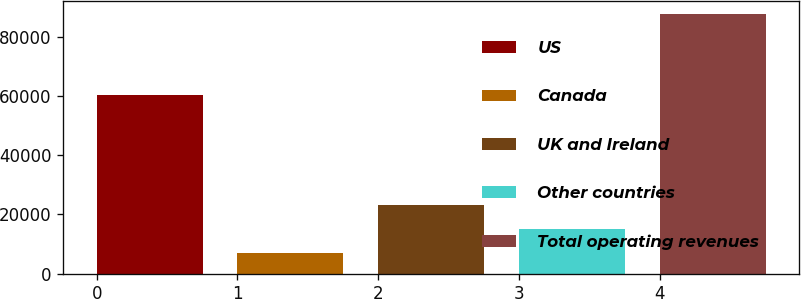Convert chart. <chart><loc_0><loc_0><loc_500><loc_500><bar_chart><fcel>US<fcel>Canada<fcel>UK and Ireland<fcel>Other countries<fcel>Total operating revenues<nl><fcel>60319<fcel>6841<fcel>23033.6<fcel>14937.3<fcel>87804<nl></chart> 